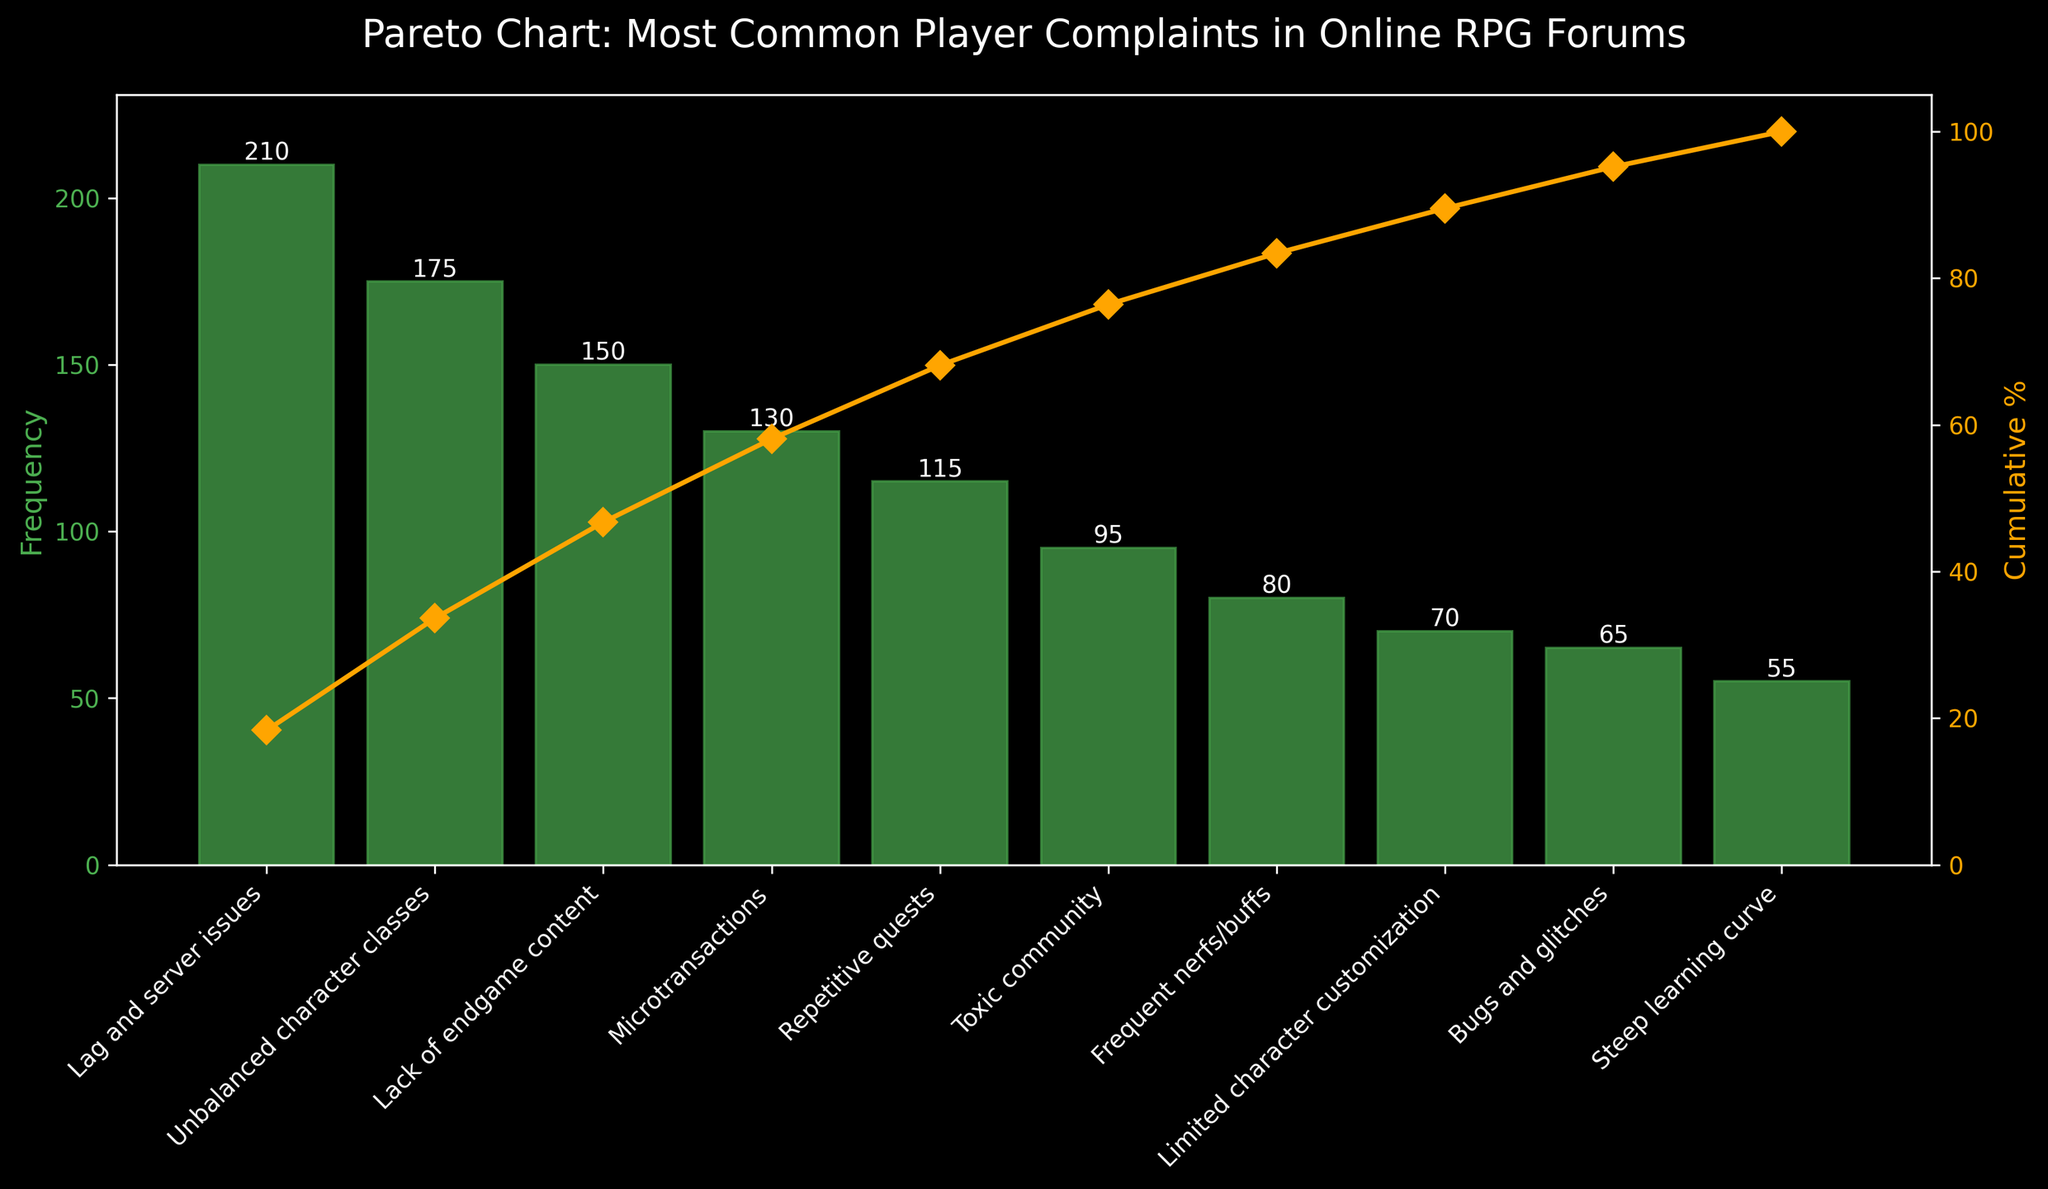What is the highest frequency complaint shown in the chart? The highest frequency is represented by the tallest bar on the chart. It is labeled "Lag and server issues" with a frequency of 210.
Answer: Lag and server issues What percentage of total complaints does "Unbalanced character classes" represent? The frequency for "Unbalanced character classes" is 175. To find the percentage: (175 / total frequency) * 100. The total frequency is the sum of all frequencies: 210 + 175 + 150 + 130 + 115 + 95 + 80 + 70 + 65 + 55 = 1145. Thus, (175 / 1145) * 100 ≈ 15.3%.
Answer: 15.3% What is the cumulative percentage after the first three issues? The cumulative percentages are calculated on the plot: 210 (Lag and server issues) + 175 (Unbalanced character classes) + 150 (Lack of endgame content) = 535. The cumulative percentage for 535 out of 1145 is (535 / 1145) * 100 ≈ 46.7%.
Answer: ≈ 46.7% Which complaint has the lowest frequency? The shortest bar on the bar chart represents the complaint with the lowest frequency, which is labeled "Steep learning curve" at 55.
Answer: Steep learning curve By how many complaints does "Microtransactions" exceed "Bugs and glitches"? Compare the frequencies directly: Microtransactions (130) – Bugs and glitches (65) = 65.
Answer: 65 Which issues make up at least 75% of the complaints? Look for where the cumulative percentage exceeds 75% on the cumulative line in the chart. The complaints making up to 75% are up to and including "Toxic community": Lag and server issues (210), Unbalanced character classes (175), Lack of endgame content (150), Microtransactions (130), Repetitive quests (115), Toxic community (95), which cumulatively exceed 75%.
Answer: Up to Toxic community How does the cumulative percentage curve behave after the fifth complaint? After the fifth complaint, "Repetitive quests," the curve continues to rise but at a slower rate, indicating that later complaints make up less of the total frequency.
Answer: Slower rise Between which two complaints does the cumulative percentage cross 50%? 50% of the total complaints (1145) is at a frequency of 572.5. It crosses this percentage between "Lag and server issues" (210) + "Unbalanced character classes" (175) + "Lack of endgame content" (150) = 535 and the next addition crosses 572.5.
Answer: After Lack of endgame content, before Microtransactions Which complaint category immediately follows "Microtransactions" in frequency? By looking at the order of bar heights, "Repetitive quests" (115) follows "Microtransactions" (130).
Answer: Repetitive quests 